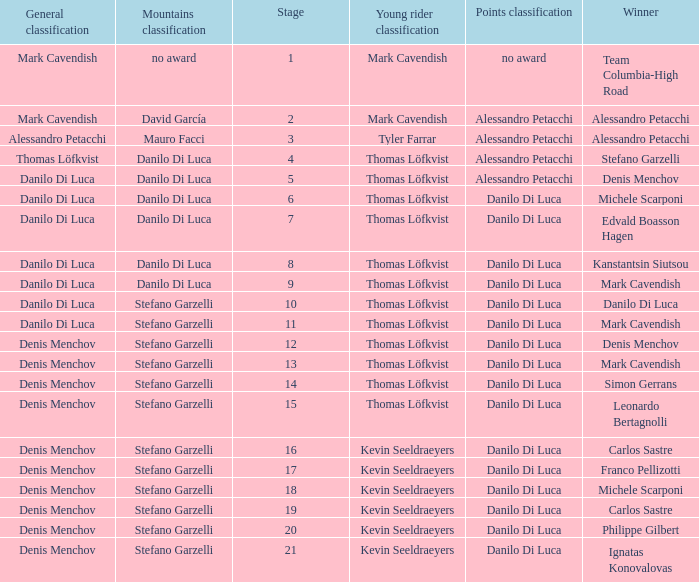When danilo di luca is the winner who is the general classification?  Danilo Di Luca. 